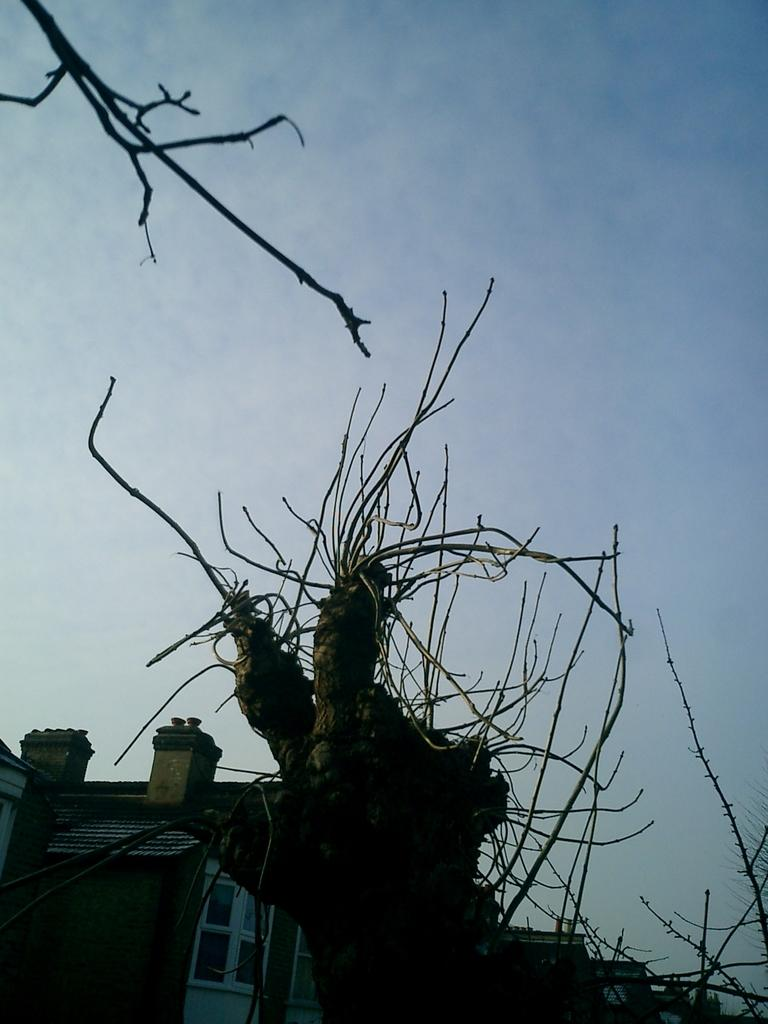What is located in the foreground of the image? There is a tree in the foreground of the image. What can be seen in the background of the image? There are houses and the sky visible in the background of the image. What color is the shirt worn by the tree in the image? There is no shirt present in the image, as the main subject is a tree, which does not wear clothing. 